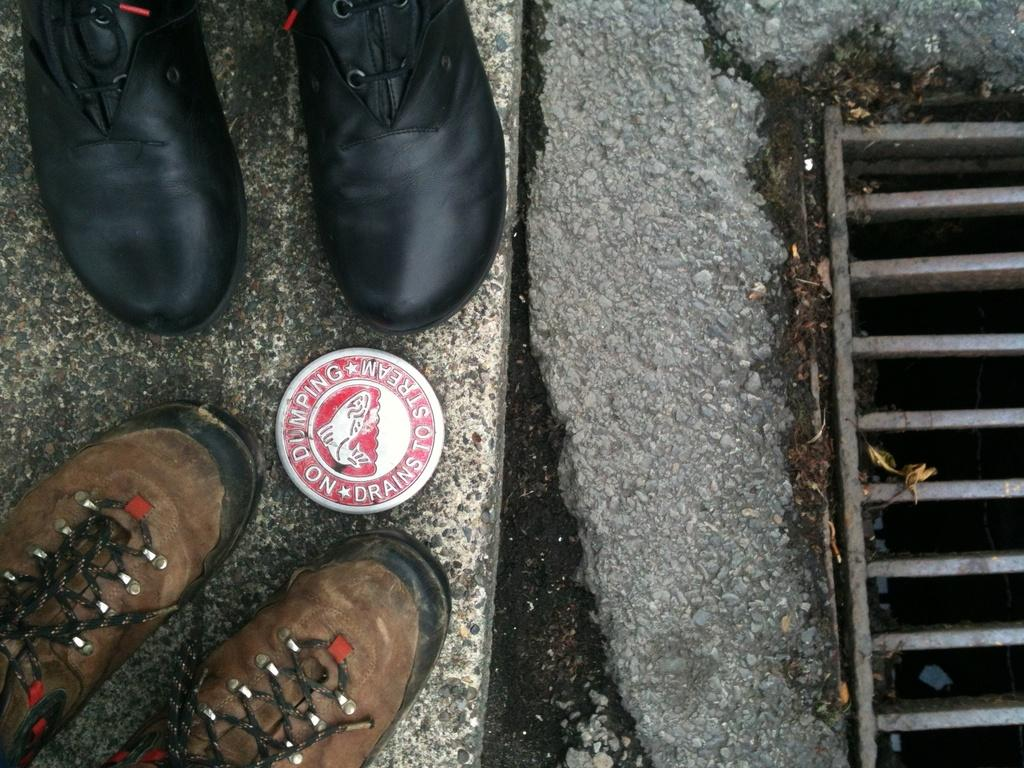What type of footwear is visible in the image? There are a pair of shoes in the image. What type of infrastructure can be seen in the image? There is a manhole in the image. What is the color combination of the object in the image? The object in the image has a red and white color combination. What is the color of the surface in the image? The surface in the image is grey and white in color. How many ants are crawling on the shoes in the image? There are no ants present in the image; it only features a pair of shoes, a manhole, and a red and white object on a grey and white surface. What type of umbrella is being used to cover the manhole in the image? There is no umbrella present in the image; the manhole is visible without any cover. 